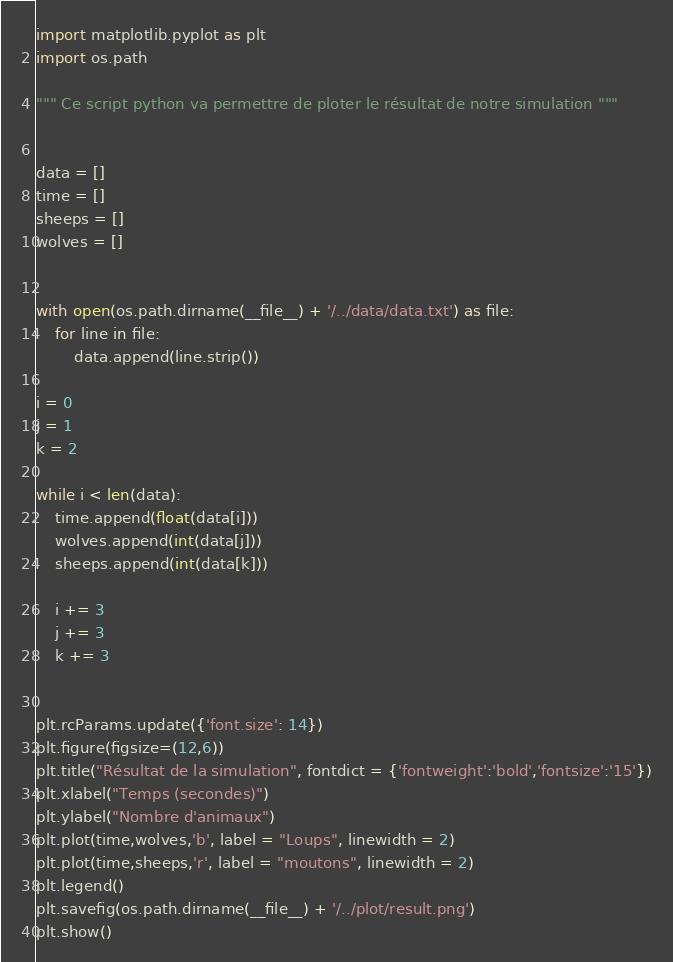Convert code to text. <code><loc_0><loc_0><loc_500><loc_500><_Python_>import matplotlib.pyplot as plt
import os.path

""" Ce script python va permettre de ploter le résultat de notre simulation """


data = []
time = []
sheeps = []
wolves = []


with open(os.path.dirname(__file__) + '/../data/data.txt') as file:
    for line in file:
        data.append(line.strip())

i = 0
j = 1
k = 2

while i < len(data):
    time.append(float(data[i]))
    wolves.append(int(data[j]))
    sheeps.append(int(data[k]))

    i += 3
    j += 3
    k += 3


plt.rcParams.update({'font.size': 14})
plt.figure(figsize=(12,6))
plt.title("Résultat de la simulation", fontdict = {'fontweight':'bold','fontsize':'15'})
plt.xlabel("Temps (secondes)")
plt.ylabel("Nombre d'animaux")
plt.plot(time,wolves,'b', label = "Loups", linewidth = 2)
plt.plot(time,sheeps,'r', label = "moutons", linewidth = 2)
plt.legend()
plt.savefig(os.path.dirname(__file__) + '/../plot/result.png')
plt.show()
</code> 